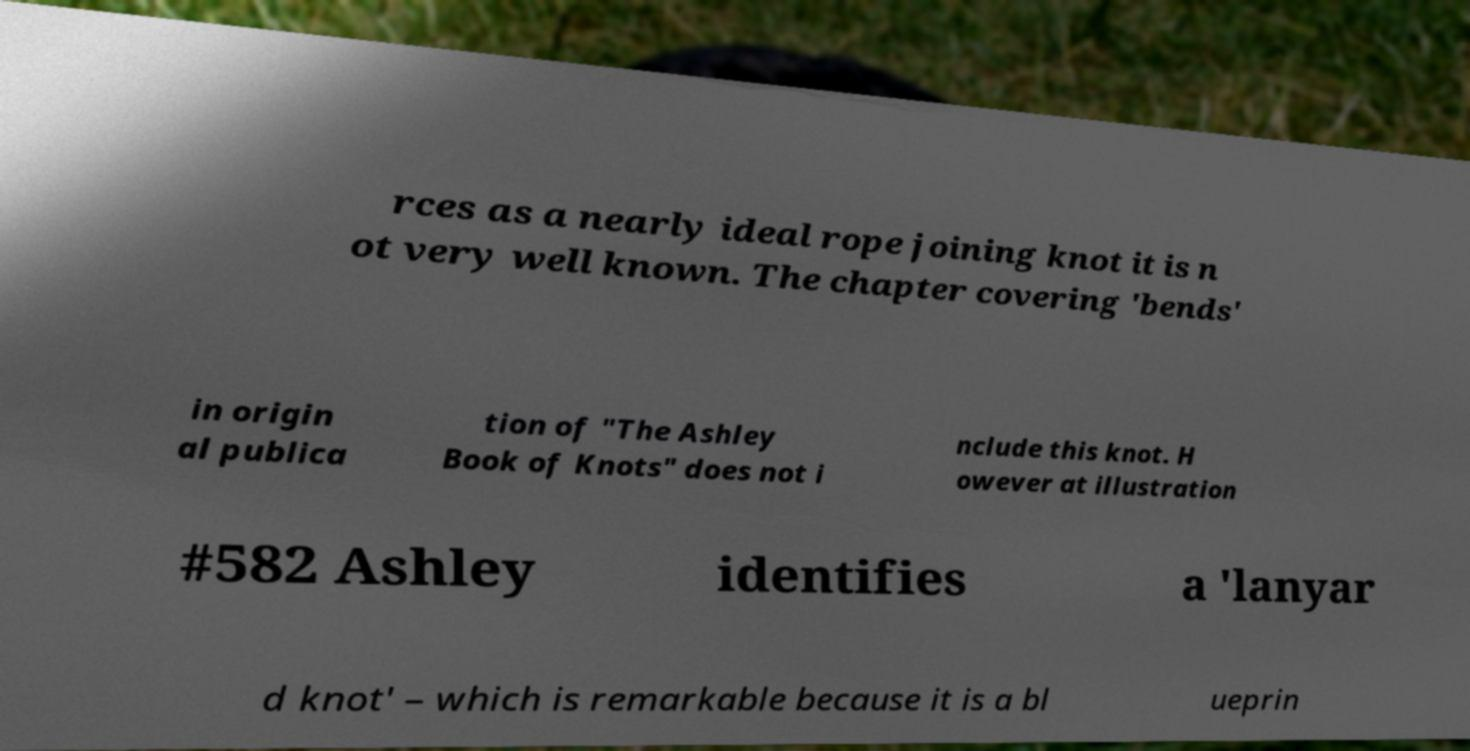Can you accurately transcribe the text from the provided image for me? rces as a nearly ideal rope joining knot it is n ot very well known. The chapter covering 'bends' in origin al publica tion of "The Ashley Book of Knots" does not i nclude this knot. H owever at illustration #582 Ashley identifies a 'lanyar d knot' – which is remarkable because it is a bl ueprin 